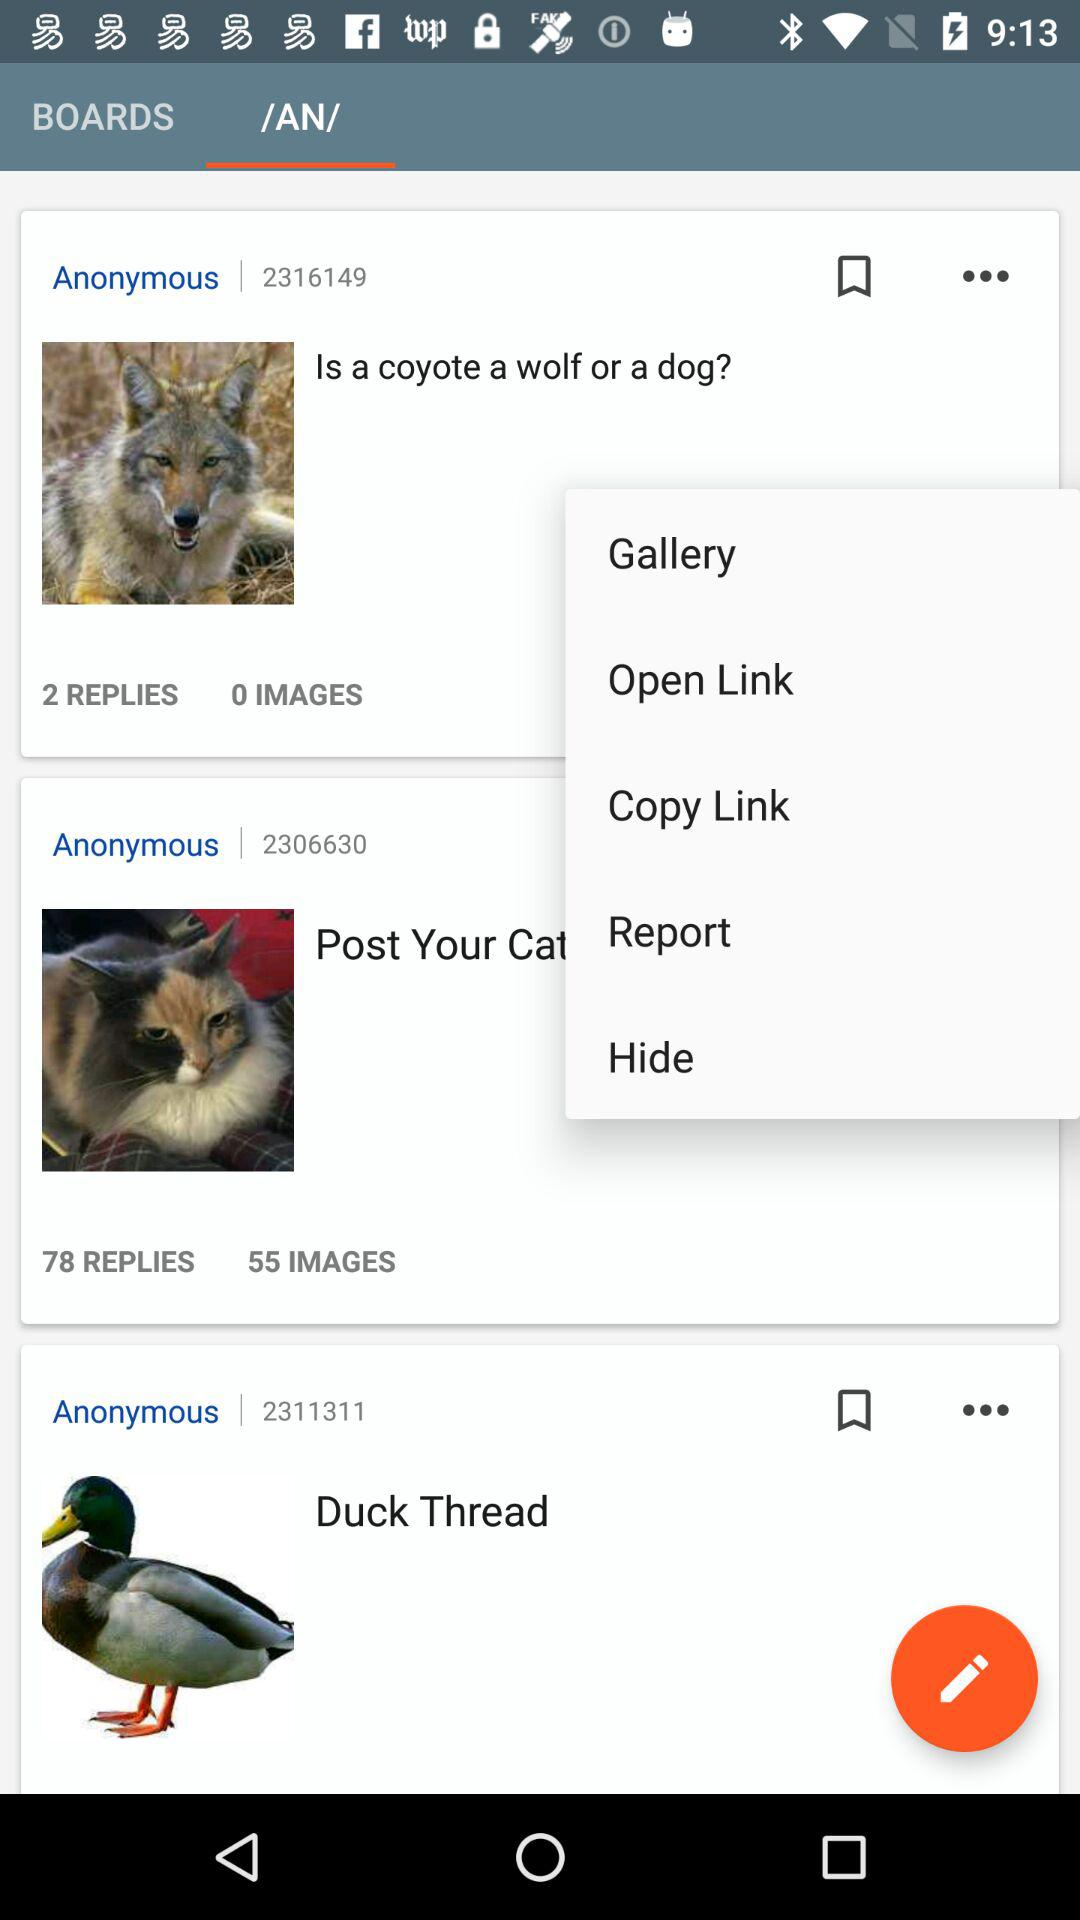How many replies are there for "Is a coyote a wolf or a dog?"? There are 2 replies. 